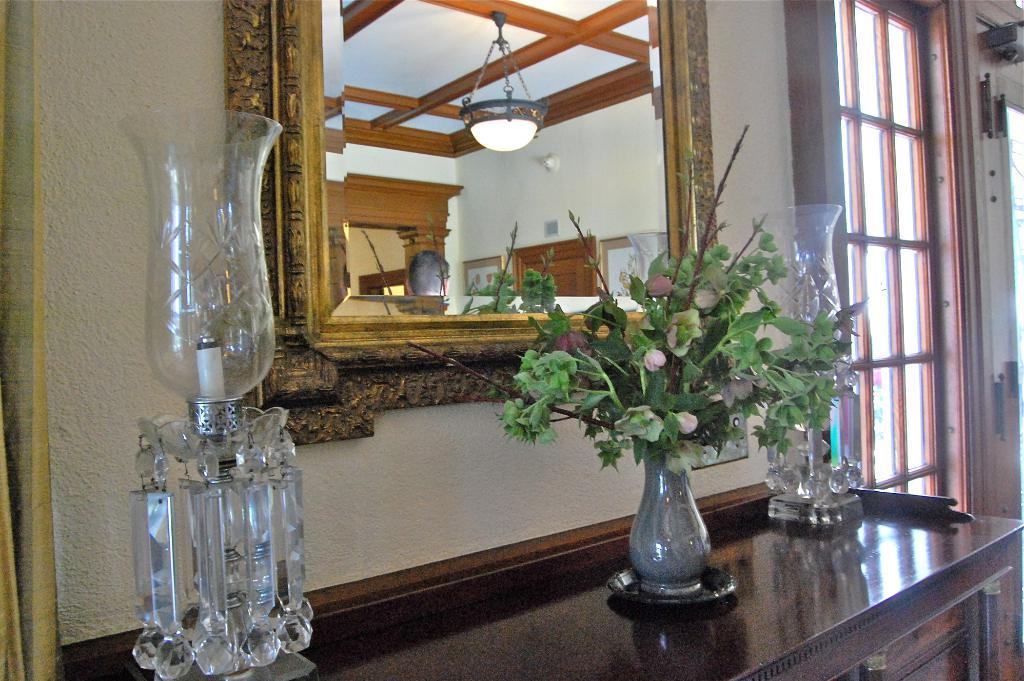What is the main object in the middle of the image? There is a mirror in the middle of the image. What is placed in front of the mirror? There is a flower vase and a candle light in front of the mirror. Where is the door located in the image? The door is on the right side of the image. What material is associated with the door? There is glass associated with the door. Can you describe the setting of the image? The image was taken inside a house. What type of food is being prepared on the spade in the image? There is no spade or food preparation visible in the image. What kind of pest can be seen crawling on the mirror in the image? There are no pests present in the image; the mirror is clean and clear. 